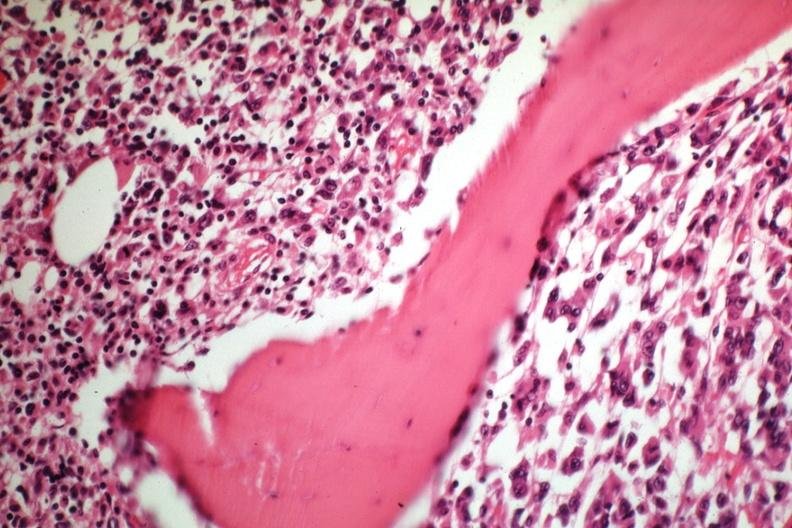what does this image show?
Answer the question using a single word or phrase. Tumor well shown gross is slide 